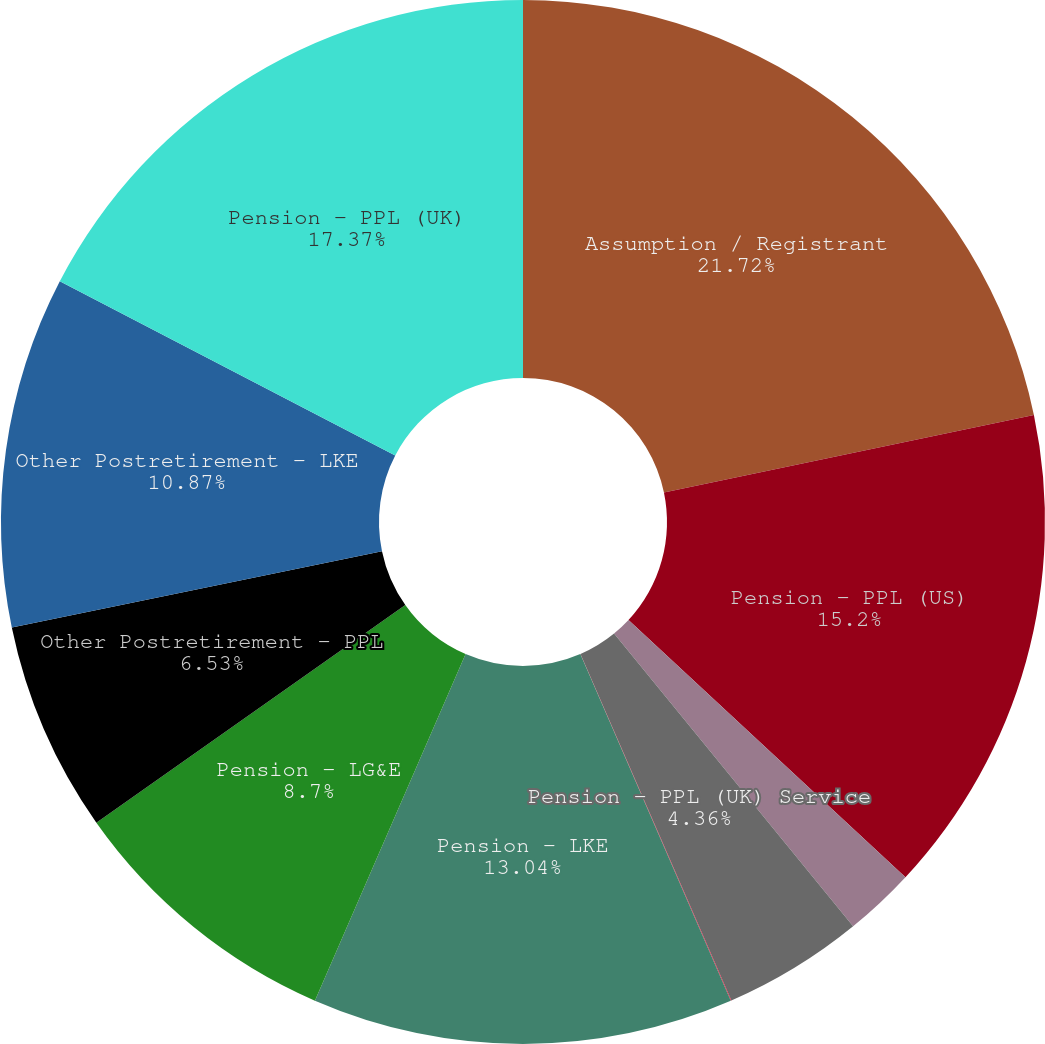<chart> <loc_0><loc_0><loc_500><loc_500><pie_chart><fcel>Assumption / Registrant<fcel>Pension - PPL (US)<fcel>Pension - PPL (UK) Obligations<fcel>Pension - PPL (UK) Service<fcel>Pension - PPL (UK) Interest<fcel>Pension - LKE<fcel>Pension - LG&E<fcel>Other Postretirement - PPL<fcel>Other Postretirement - LKE<fcel>Pension - PPL (UK)<nl><fcel>21.71%<fcel>15.2%<fcel>2.19%<fcel>4.36%<fcel>0.02%<fcel>13.04%<fcel>8.7%<fcel>6.53%<fcel>10.87%<fcel>17.37%<nl></chart> 